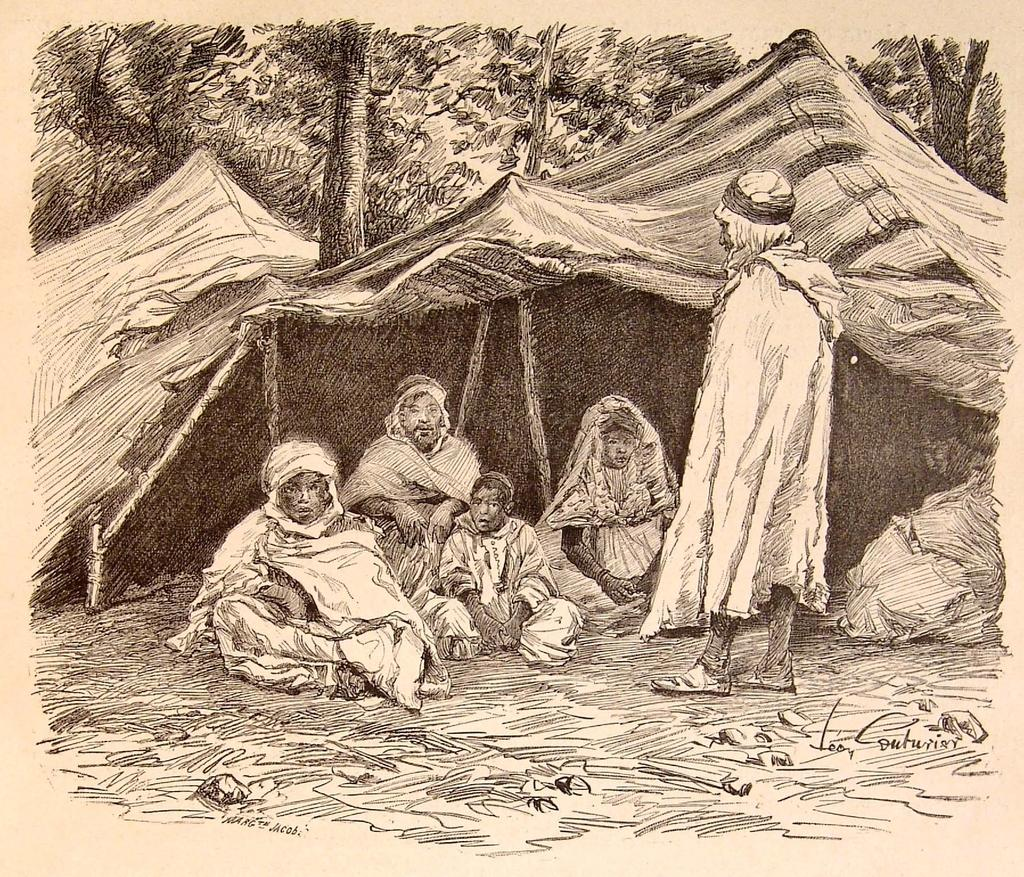What is depicted on the poster in the image? There is a poster with a painting in the image. Who or what can be seen in the image besides the poster? There are persons and a tent visible in the image. What type of natural vegetation is present in the image? There are trees in the image. How many books can be seen on the poster in the image? There are no books visible on the poster in the image; it features a painting. 